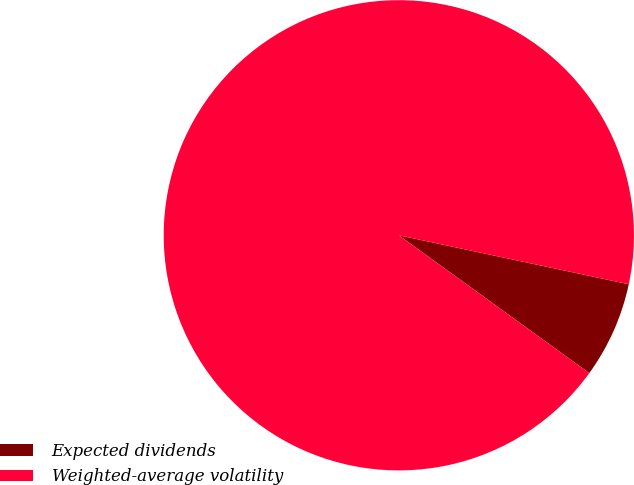Convert chart to OTSL. <chart><loc_0><loc_0><loc_500><loc_500><pie_chart><fcel>Expected dividends<fcel>Weighted-average volatility<nl><fcel>6.63%<fcel>93.37%<nl></chart> 